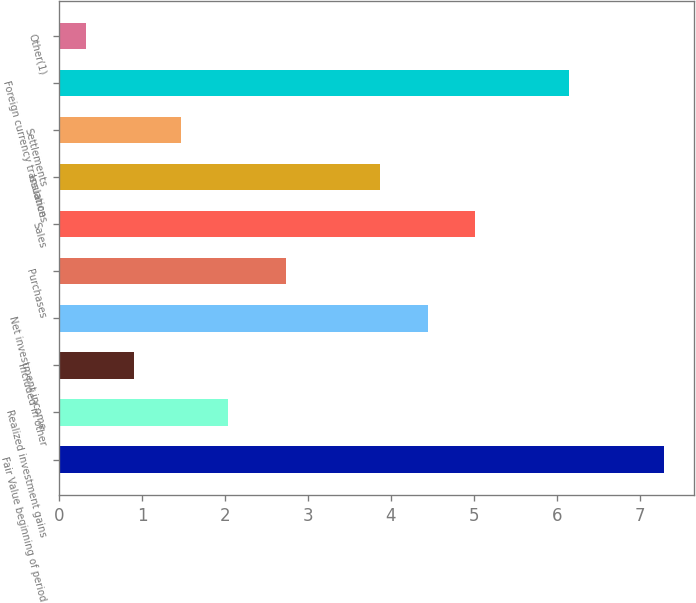<chart> <loc_0><loc_0><loc_500><loc_500><bar_chart><fcel>Fair Value beginning of period<fcel>Realized investment gains<fcel>Included in other<fcel>Net investment income<fcel>Purchases<fcel>Sales<fcel>Issuances<fcel>Settlements<fcel>Foreign currency translation<fcel>Other(1)<nl><fcel>7.29<fcel>2.04<fcel>0.9<fcel>4.44<fcel>2.73<fcel>5.01<fcel>3.87<fcel>1.47<fcel>6.15<fcel>0.33<nl></chart> 